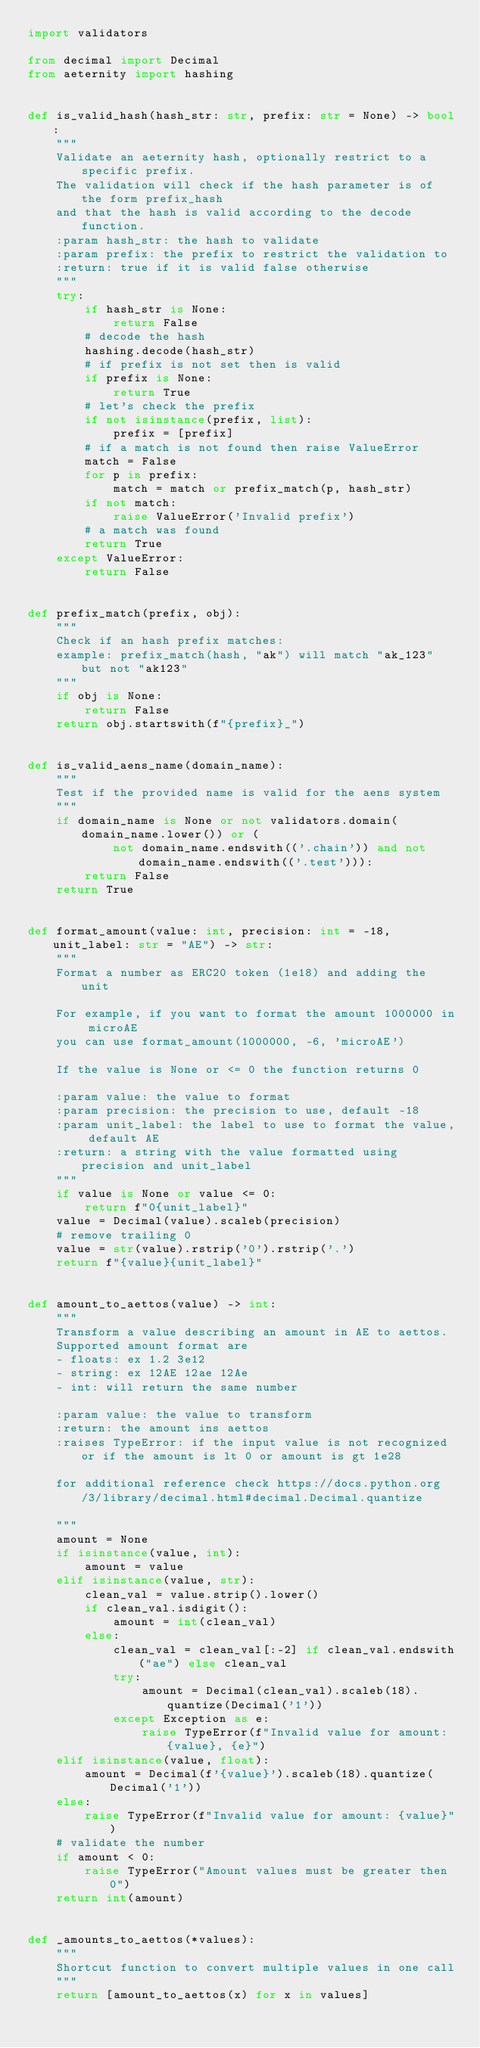Convert code to text. <code><loc_0><loc_0><loc_500><loc_500><_Python_>import validators

from decimal import Decimal
from aeternity import hashing


def is_valid_hash(hash_str: str, prefix: str = None) -> bool:
    """
    Validate an aeternity hash, optionally restrict to a specific prefix.
    The validation will check if the hash parameter is of the form prefix_hash
    and that the hash is valid according to the decode function.
    :param hash_str: the hash to validate
    :param prefix: the prefix to restrict the validation to
    :return: true if it is valid false otherwise
    """
    try:
        if hash_str is None:
            return False
        # decode the hash
        hashing.decode(hash_str)
        # if prefix is not set then is valid
        if prefix is None:
            return True
        # let's check the prefix
        if not isinstance(prefix, list):
            prefix = [prefix]
        # if a match is not found then raise ValueError
        match = False
        for p in prefix:
            match = match or prefix_match(p, hash_str)
        if not match:
            raise ValueError('Invalid prefix')
        # a match was found
        return True
    except ValueError:
        return False


def prefix_match(prefix, obj):
    """
    Check if an hash prefix matches:
    example: prefix_match(hash, "ak") will match "ak_123" but not "ak123"
    """
    if obj is None:
        return False
    return obj.startswith(f"{prefix}_")


def is_valid_aens_name(domain_name):
    """
    Test if the provided name is valid for the aens system
    """
    if domain_name is None or not validators.domain(domain_name.lower()) or (
            not domain_name.endswith(('.chain')) and not domain_name.endswith(('.test'))):
        return False
    return True


def format_amount(value: int, precision: int = -18, unit_label: str = "AE") -> str:
    """
    Format a number as ERC20 token (1e18) and adding the unit

    For example, if you want to format the amount 1000000 in microAE
    you can use format_amount(1000000, -6, 'microAE')

    If the value is None or <= 0 the function returns 0

    :param value: the value to format
    :param precision: the precision to use, default -18
    :param unit_label: the label to use to format the value, default AE
    :return: a string with the value formatted using precision and unit_label
    """
    if value is None or value <= 0:
        return f"0{unit_label}"
    value = Decimal(value).scaleb(precision)
    # remove trailing 0
    value = str(value).rstrip('0').rstrip('.')
    return f"{value}{unit_label}"


def amount_to_aettos(value) -> int:
    """
    Transform a value describing an amount in AE to aettos.
    Supported amount format are
    - floats: ex 1.2 3e12
    - string: ex 12AE 12ae 12Ae
    - int: will return the same number

    :param value: the value to transform
    :return: the amount ins aettos
    :raises TypeError: if the input value is not recognized or if the amount is lt 0 or amount is gt 1e28

    for additional reference check https://docs.python.org/3/library/decimal.html#decimal.Decimal.quantize

    """
    amount = None
    if isinstance(value, int):
        amount = value
    elif isinstance(value, str):
        clean_val = value.strip().lower()
        if clean_val.isdigit():
            amount = int(clean_val)
        else:
            clean_val = clean_val[:-2] if clean_val.endswith("ae") else clean_val
            try:
                amount = Decimal(clean_val).scaleb(18).quantize(Decimal('1'))
            except Exception as e:
                raise TypeError(f"Invalid value for amount: {value}, {e}")
    elif isinstance(value, float):
        amount = Decimal(f'{value}').scaleb(18).quantize(Decimal('1'))
    else:
        raise TypeError(f"Invalid value for amount: {value}")
    # validate the number
    if amount < 0:
        raise TypeError("Amount values must be greater then 0")
    return int(amount)


def _amounts_to_aettos(*values):
    """
    Shortcut function to convert multiple values in one call
    """
    return [amount_to_aettos(x) for x in values]
</code> 